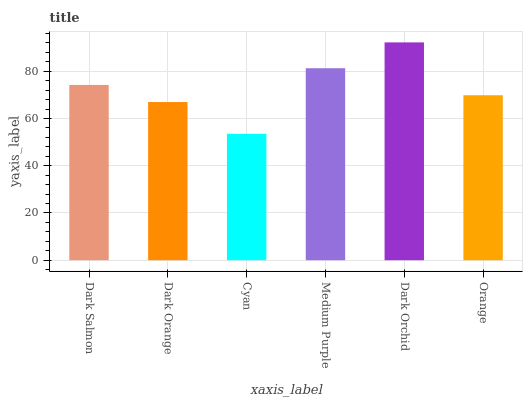Is Cyan the minimum?
Answer yes or no. Yes. Is Dark Orchid the maximum?
Answer yes or no. Yes. Is Dark Orange the minimum?
Answer yes or no. No. Is Dark Orange the maximum?
Answer yes or no. No. Is Dark Salmon greater than Dark Orange?
Answer yes or no. Yes. Is Dark Orange less than Dark Salmon?
Answer yes or no. Yes. Is Dark Orange greater than Dark Salmon?
Answer yes or no. No. Is Dark Salmon less than Dark Orange?
Answer yes or no. No. Is Dark Salmon the high median?
Answer yes or no. Yes. Is Orange the low median?
Answer yes or no. Yes. Is Orange the high median?
Answer yes or no. No. Is Dark Orchid the low median?
Answer yes or no. No. 